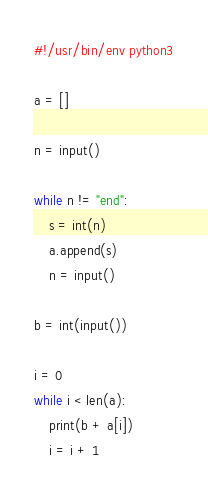<code> <loc_0><loc_0><loc_500><loc_500><_Python_>#!/usr/bin/env python3

a = []

n = input()

while n != "end":
    s = int(n)
    a.append(s)
    n = input()

b = int(input())

i = 0
while i < len(a):
    print(b + a[i])
    i = i + 1
</code> 